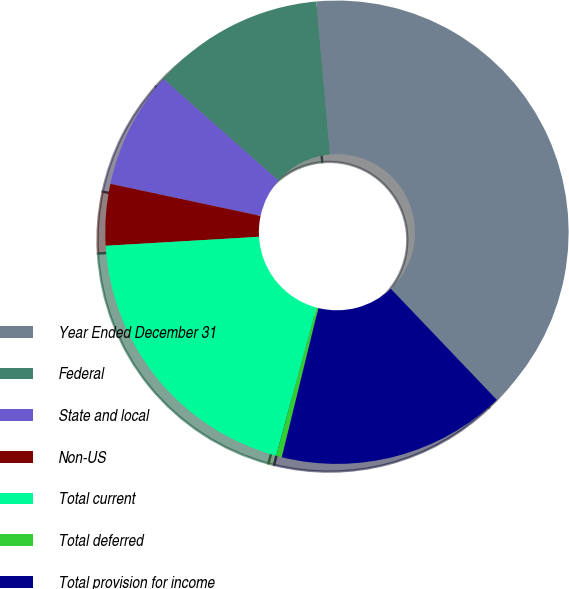Convert chart. <chart><loc_0><loc_0><loc_500><loc_500><pie_chart><fcel>Year Ended December 31<fcel>Federal<fcel>State and local<fcel>Non-US<fcel>Total current<fcel>Total deferred<fcel>Total provision for income<nl><fcel>39.29%<fcel>12.06%<fcel>8.17%<fcel>4.28%<fcel>19.84%<fcel>0.4%<fcel>15.95%<nl></chart> 